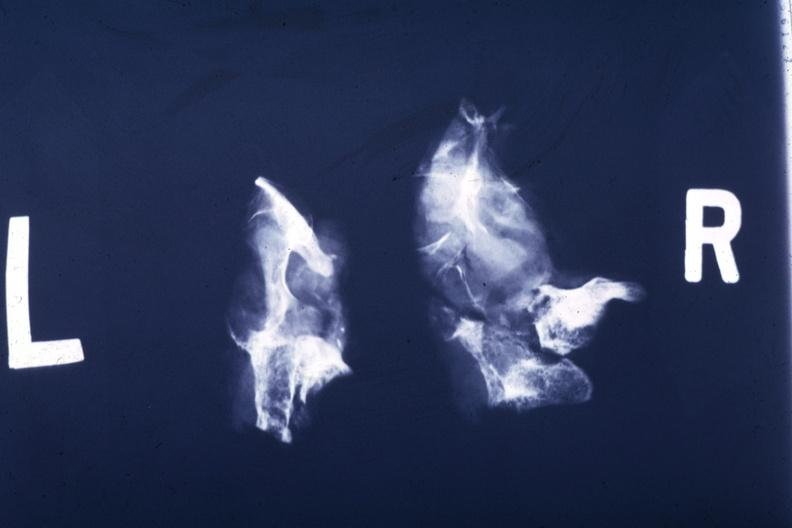s hemochromatosis present?
Answer the question using a single word or phrase. No 